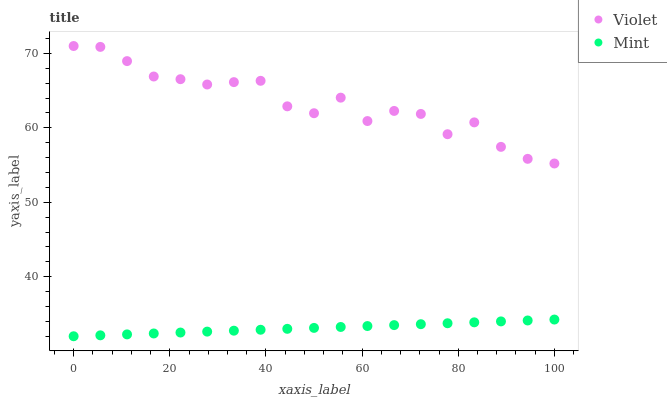Does Mint have the minimum area under the curve?
Answer yes or no. Yes. Does Violet have the maximum area under the curve?
Answer yes or no. Yes. Does Violet have the minimum area under the curve?
Answer yes or no. No. Is Mint the smoothest?
Answer yes or no. Yes. Is Violet the roughest?
Answer yes or no. Yes. Is Violet the smoothest?
Answer yes or no. No. Does Mint have the lowest value?
Answer yes or no. Yes. Does Violet have the lowest value?
Answer yes or no. No. Does Violet have the highest value?
Answer yes or no. Yes. Is Mint less than Violet?
Answer yes or no. Yes. Is Violet greater than Mint?
Answer yes or no. Yes. Does Mint intersect Violet?
Answer yes or no. No. 